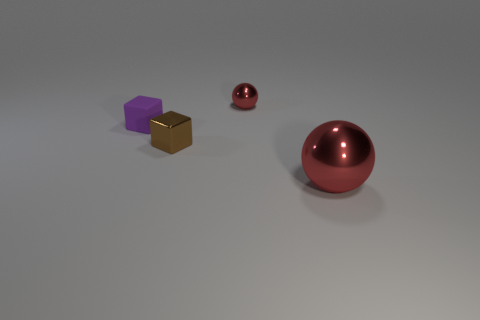How many other things are there of the same color as the shiny cube?
Ensure brevity in your answer.  0. There is another brown object that is made of the same material as the large object; what is its size?
Keep it short and to the point. Small. How many large spheres have the same color as the tiny matte cube?
Offer a terse response. 0. There is a object that is right of the small ball; does it have the same color as the small sphere?
Keep it short and to the point. Yes. Are there the same number of purple rubber cubes that are in front of the rubber cube and brown objects in front of the large red sphere?
Keep it short and to the point. Yes. Are there any other things that are the same material as the small purple object?
Keep it short and to the point. No. There is a tiny metallic object that is left of the small red metallic sphere; what is its color?
Your answer should be very brief. Brown. Are there the same number of spheres left of the large red sphere and small brown metal cylinders?
Your answer should be compact. No. What number of other things are there of the same shape as the purple thing?
Give a very brief answer. 1. There is a purple matte block; how many red spheres are in front of it?
Make the answer very short. 1. 